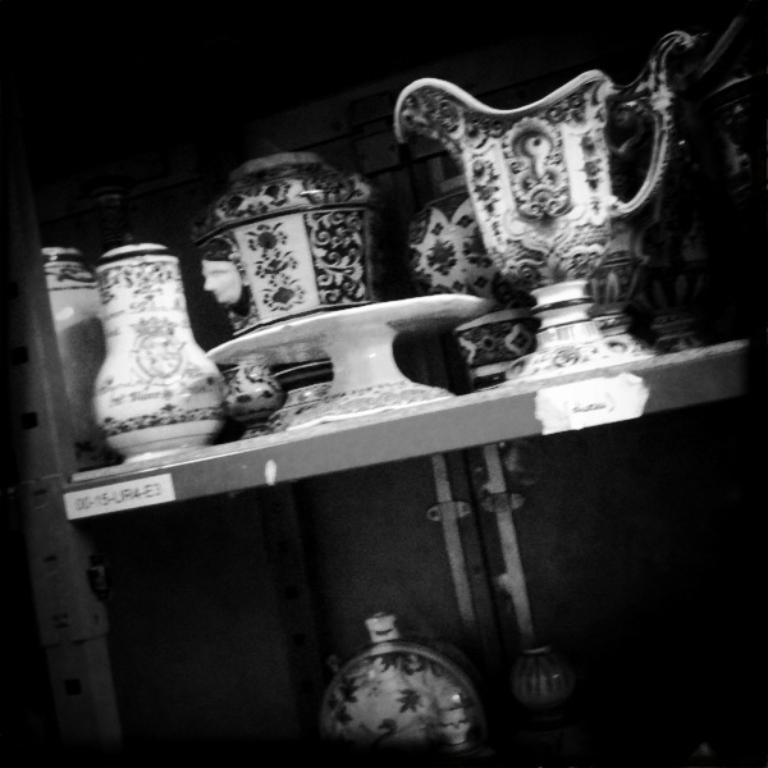What is the color scheme of the image? The image is black and white. What can be seen in the image besides the color scheme? There is a rack in the image. What is placed on the rack? Ceramic jars are placed on the rack. What color is the background of the image? The background of the image is black in color. What type of answer can be seen written on the board in the image? There is no board present in the image, so no answers can be seen. 